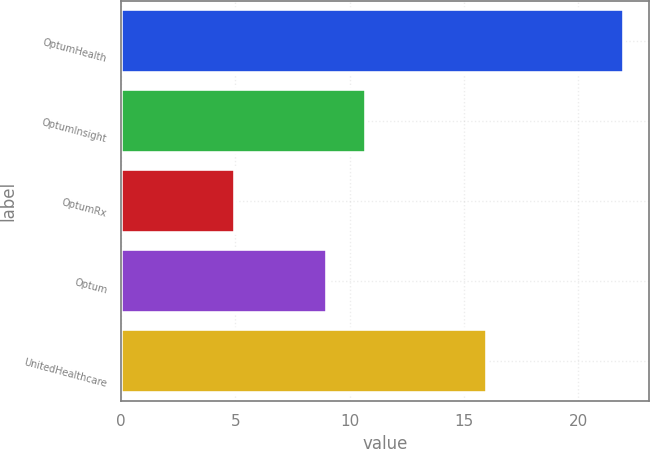Convert chart. <chart><loc_0><loc_0><loc_500><loc_500><bar_chart><fcel>OptumHealth<fcel>OptumInsight<fcel>OptumRx<fcel>Optum<fcel>UnitedHealthcare<nl><fcel>22<fcel>10.7<fcel>5<fcel>9<fcel>16<nl></chart> 